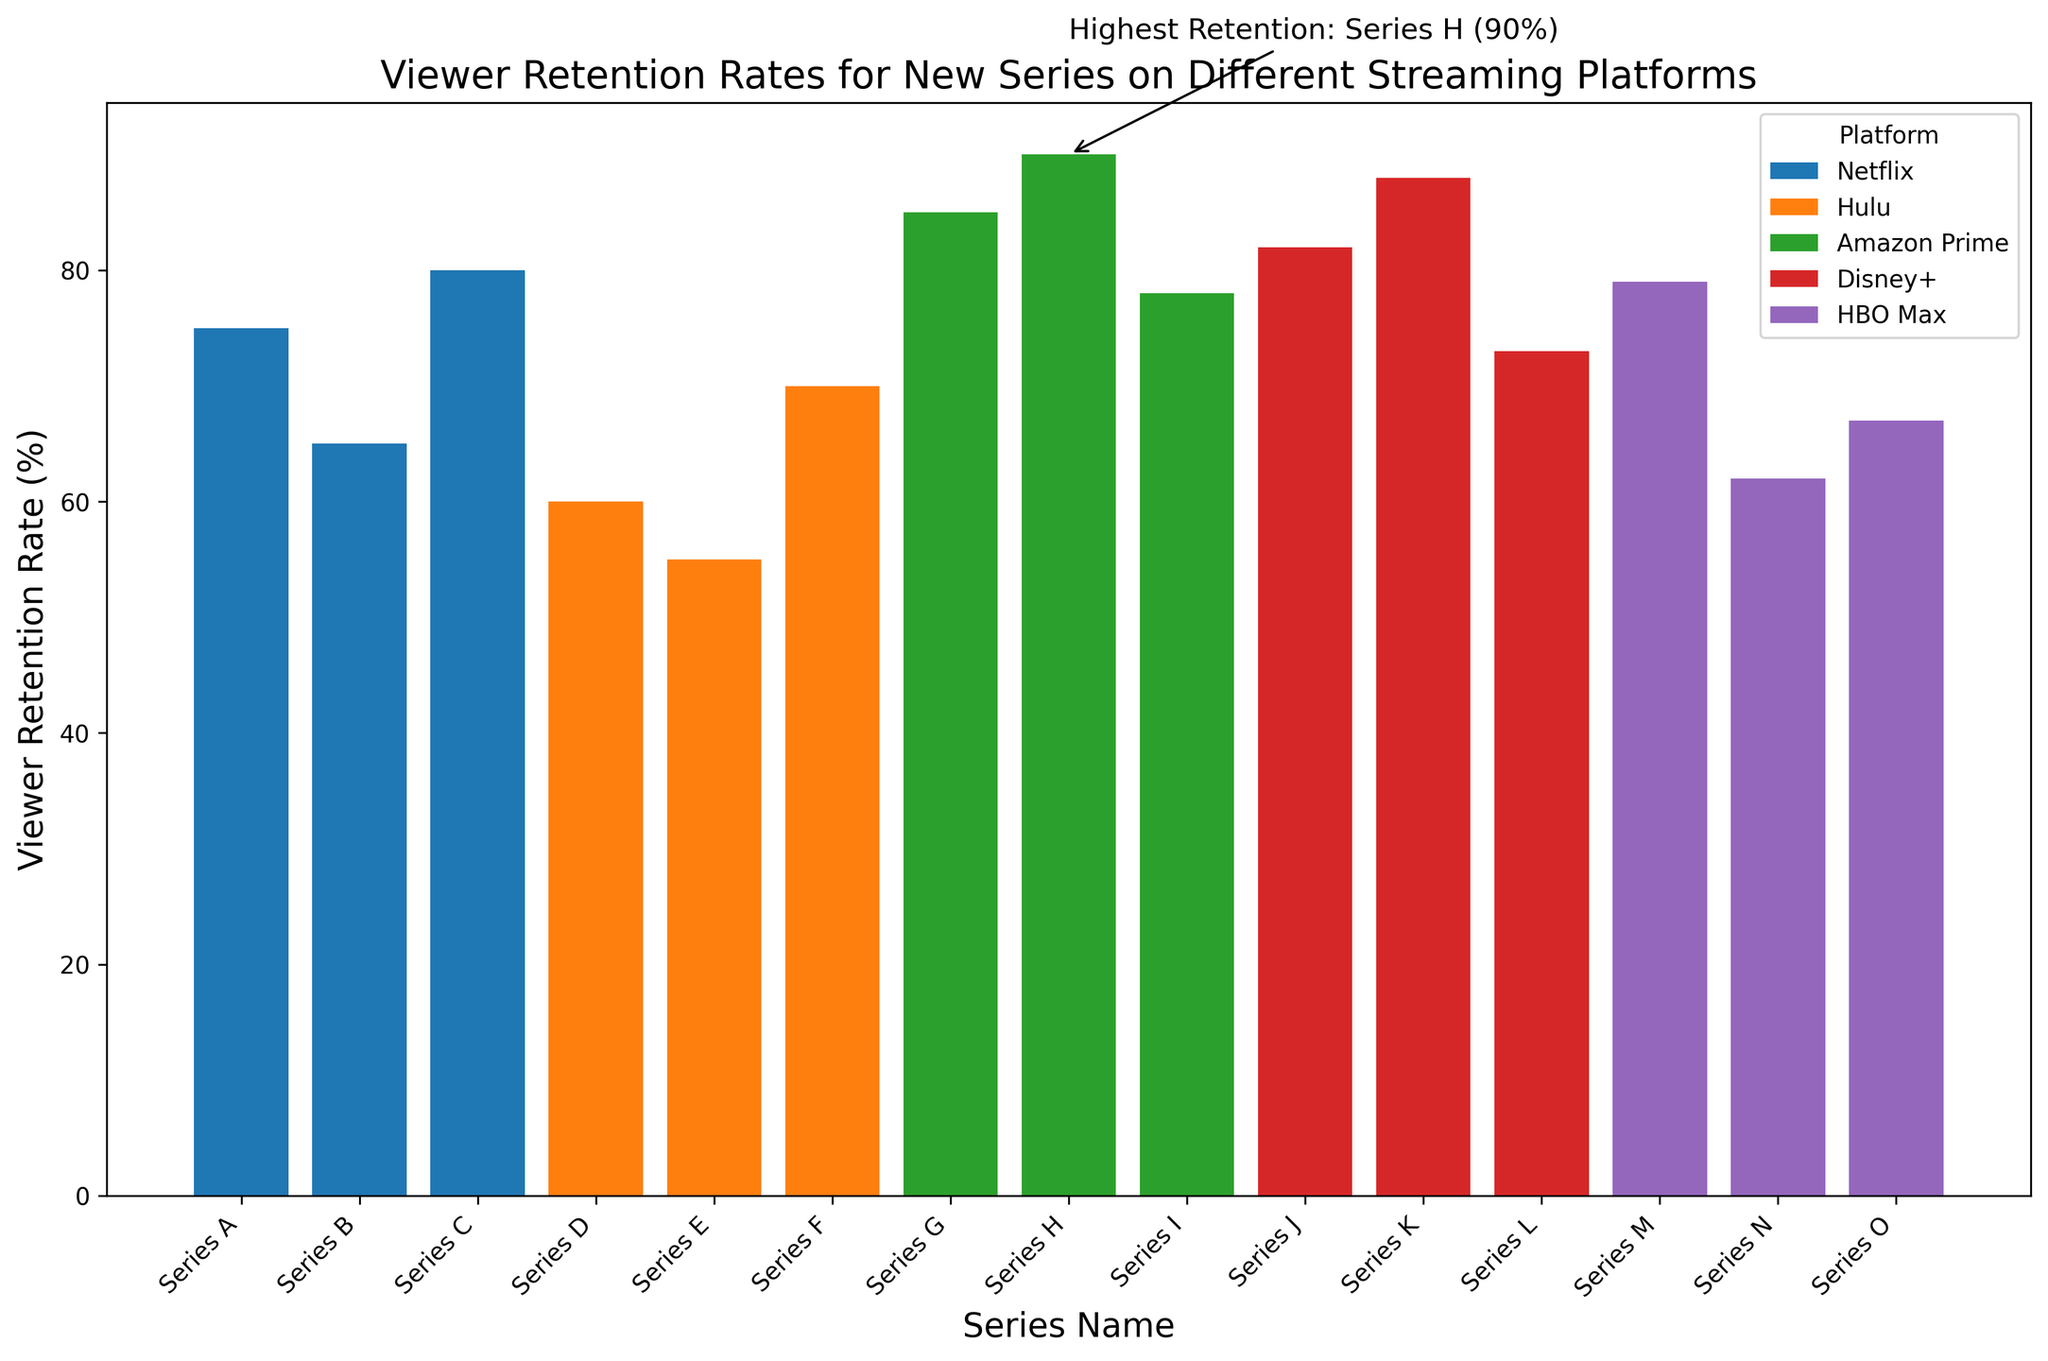What's the highest viewer retention rate? The highest viewer retention rate is annotated in the figure. It's for Series H with a rate of 90%. The annotation points to this series and clearly states the retention rate.
Answer: Series H with 90% Which platform has the series with the highest retention rate? By looking at the annotation, we see that Series H has the highest retention rate. Series H belongs to Amazon Prime. Therefore, Amazon Prime has the series with the highest retention rate.
Answer: Amazon Prime Which platform has the lowest average viewer retention rate? Calculate the average viewer retention rate for each platform: 
Netflix: (75 + 65 + 80) / 3 = 73.33 
Hulu: (60 + 55 + 70) / 3 = 61.67 
Amazon Prime: (85 + 90 + 78) / 3 = 84.33 
Disney+: (82 + 88 + 73) / 3 = 81 
HBO Max: (79 + 62 + 67) / 3 = 69.33 
The lowest average viewer retention rate is for Hulu.
Answer: Hulu Which series on Disney+ has the highest retention rate? Look at the bars for Disney+ series. Series K has the tallest bar, which means it has the highest retention rate among Disney+ series.
Answer: Series K Is the average retention rate of the series on Amazon Prime greater than the average retention rate of the series on Netflix? Calculate the averages: 
Amazon Prime: (85 + 90 + 78) / 3 = 84.33 
Netflix: (75 + 65 + 80) / 3 = 73.33 
84.33 (Amazon Prime) is greater than 73.33 (Netflix).
Answer: Yes Which platform has the most varied retention rates among its series? The variation can be assessed visually by the spread of bar heights. Series on Hulu show the most variation in height compared to other platforms. They range from 55% to 70%, indicating a variety of retention rates.
Answer: Hulu Compare the retention rates of Series F and Series I. Which one is higher? Look at the bars for Series F and Series I. Series F (Hulu) has a retention rate of 70%, and Series I (Amazon Prime) has a retention rate of 78%. So, Series I has a higher retention rate.
Answer: Series I What is the retention rate difference between the series with the highest and lowest rates on HBO Max? Identify the highest and lowest retention rates for HBO Max: 
Highest: Series M with 79% 
Lowest: Series N with 62% 
Difference: 79% - 62% = 17%
Answer: 17% 